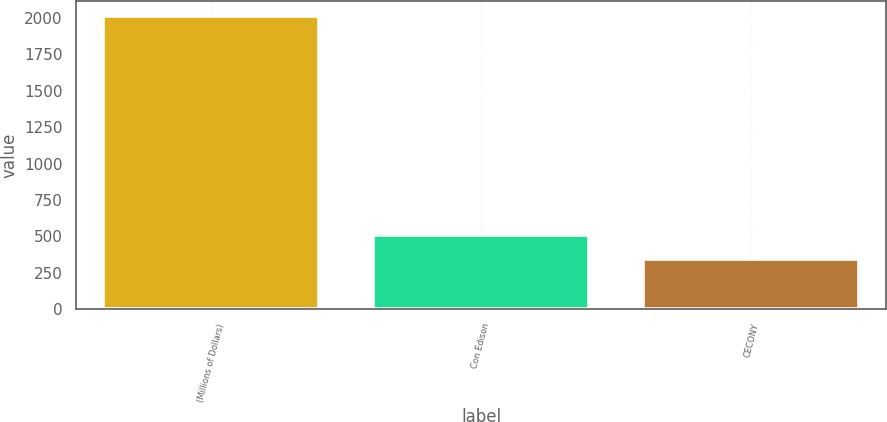<chart> <loc_0><loc_0><loc_500><loc_500><bar_chart><fcel>(Millions of Dollars)<fcel>Con Edison<fcel>CECONY<nl><fcel>2014<fcel>510.1<fcel>343<nl></chart> 